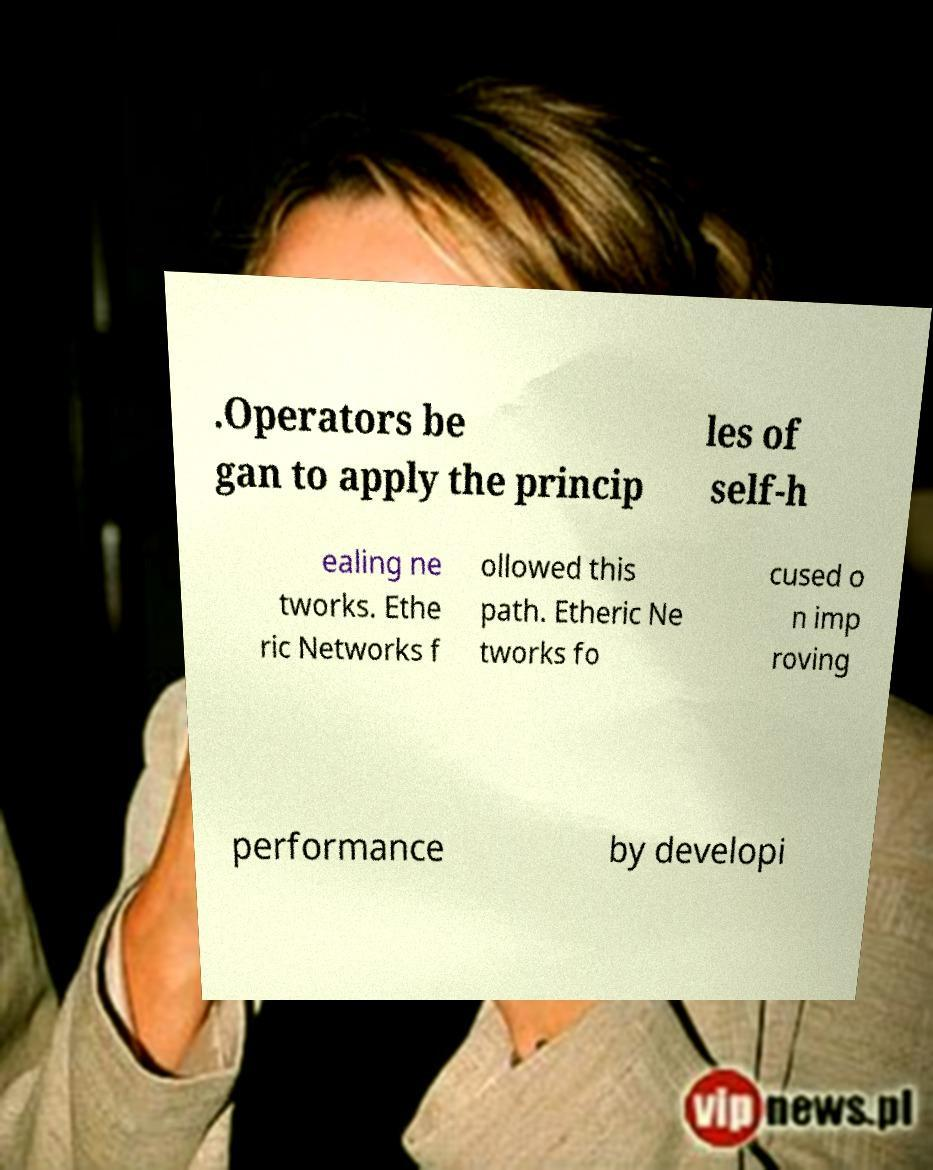Can you read and provide the text displayed in the image?This photo seems to have some interesting text. Can you extract and type it out for me? .Operators be gan to apply the princip les of self-h ealing ne tworks. Ethe ric Networks f ollowed this path. Etheric Ne tworks fo cused o n imp roving performance by developi 